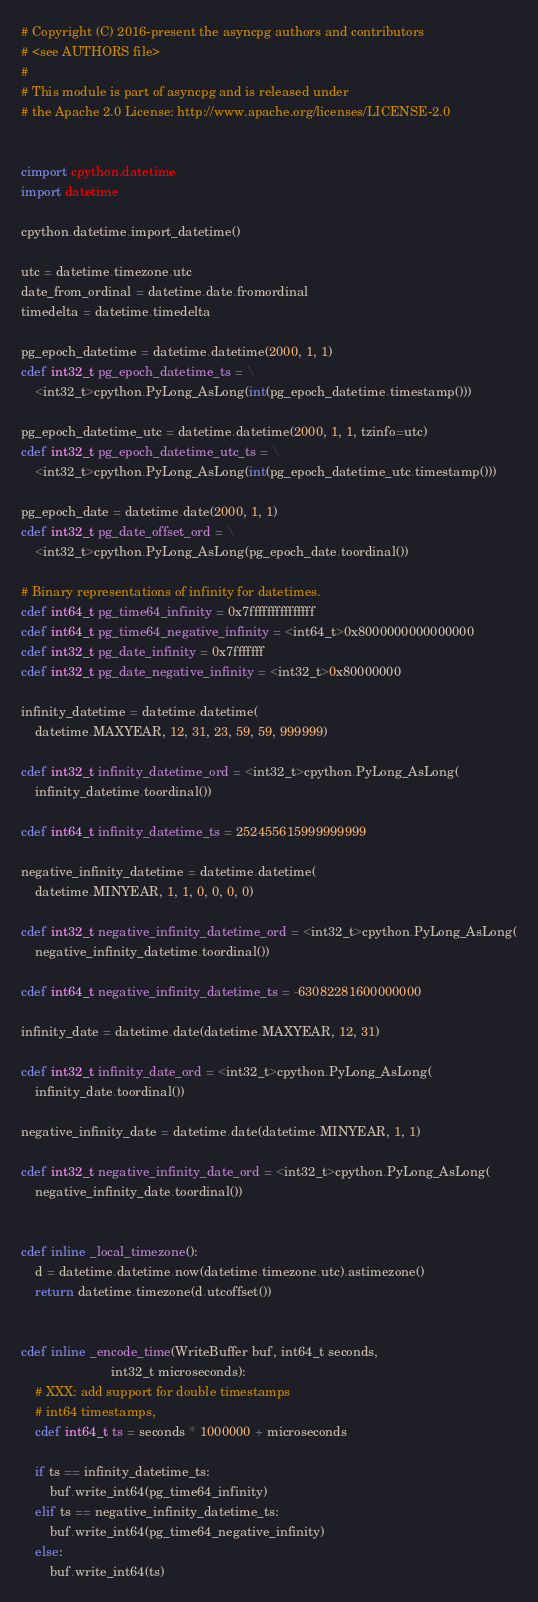<code> <loc_0><loc_0><loc_500><loc_500><_Cython_># Copyright (C) 2016-present the asyncpg authors and contributors
# <see AUTHORS file>
#
# This module is part of asyncpg and is released under
# the Apache 2.0 License: http://www.apache.org/licenses/LICENSE-2.0


cimport cpython.datetime
import datetime

cpython.datetime.import_datetime()

utc = datetime.timezone.utc
date_from_ordinal = datetime.date.fromordinal
timedelta = datetime.timedelta

pg_epoch_datetime = datetime.datetime(2000, 1, 1)
cdef int32_t pg_epoch_datetime_ts = \
    <int32_t>cpython.PyLong_AsLong(int(pg_epoch_datetime.timestamp()))

pg_epoch_datetime_utc = datetime.datetime(2000, 1, 1, tzinfo=utc)
cdef int32_t pg_epoch_datetime_utc_ts = \
    <int32_t>cpython.PyLong_AsLong(int(pg_epoch_datetime_utc.timestamp()))

pg_epoch_date = datetime.date(2000, 1, 1)
cdef int32_t pg_date_offset_ord = \
    <int32_t>cpython.PyLong_AsLong(pg_epoch_date.toordinal())

# Binary representations of infinity for datetimes.
cdef int64_t pg_time64_infinity = 0x7fffffffffffffff
cdef int64_t pg_time64_negative_infinity = <int64_t>0x8000000000000000
cdef int32_t pg_date_infinity = 0x7fffffff
cdef int32_t pg_date_negative_infinity = <int32_t>0x80000000

infinity_datetime = datetime.datetime(
    datetime.MAXYEAR, 12, 31, 23, 59, 59, 999999)

cdef int32_t infinity_datetime_ord = <int32_t>cpython.PyLong_AsLong(
    infinity_datetime.toordinal())

cdef int64_t infinity_datetime_ts = 252455615999999999

negative_infinity_datetime = datetime.datetime(
    datetime.MINYEAR, 1, 1, 0, 0, 0, 0)

cdef int32_t negative_infinity_datetime_ord = <int32_t>cpython.PyLong_AsLong(
    negative_infinity_datetime.toordinal())

cdef int64_t negative_infinity_datetime_ts = -63082281600000000

infinity_date = datetime.date(datetime.MAXYEAR, 12, 31)

cdef int32_t infinity_date_ord = <int32_t>cpython.PyLong_AsLong(
    infinity_date.toordinal())

negative_infinity_date = datetime.date(datetime.MINYEAR, 1, 1)

cdef int32_t negative_infinity_date_ord = <int32_t>cpython.PyLong_AsLong(
    negative_infinity_date.toordinal())


cdef inline _local_timezone():
    d = datetime.datetime.now(datetime.timezone.utc).astimezone()
    return datetime.timezone(d.utcoffset())


cdef inline _encode_time(WriteBuffer buf, int64_t seconds,
                         int32_t microseconds):
    # XXX: add support for double timestamps
    # int64 timestamps,
    cdef int64_t ts = seconds * 1000000 + microseconds

    if ts == infinity_datetime_ts:
        buf.write_int64(pg_time64_infinity)
    elif ts == negative_infinity_datetime_ts:
        buf.write_int64(pg_time64_negative_infinity)
    else:
        buf.write_int64(ts)

</code> 